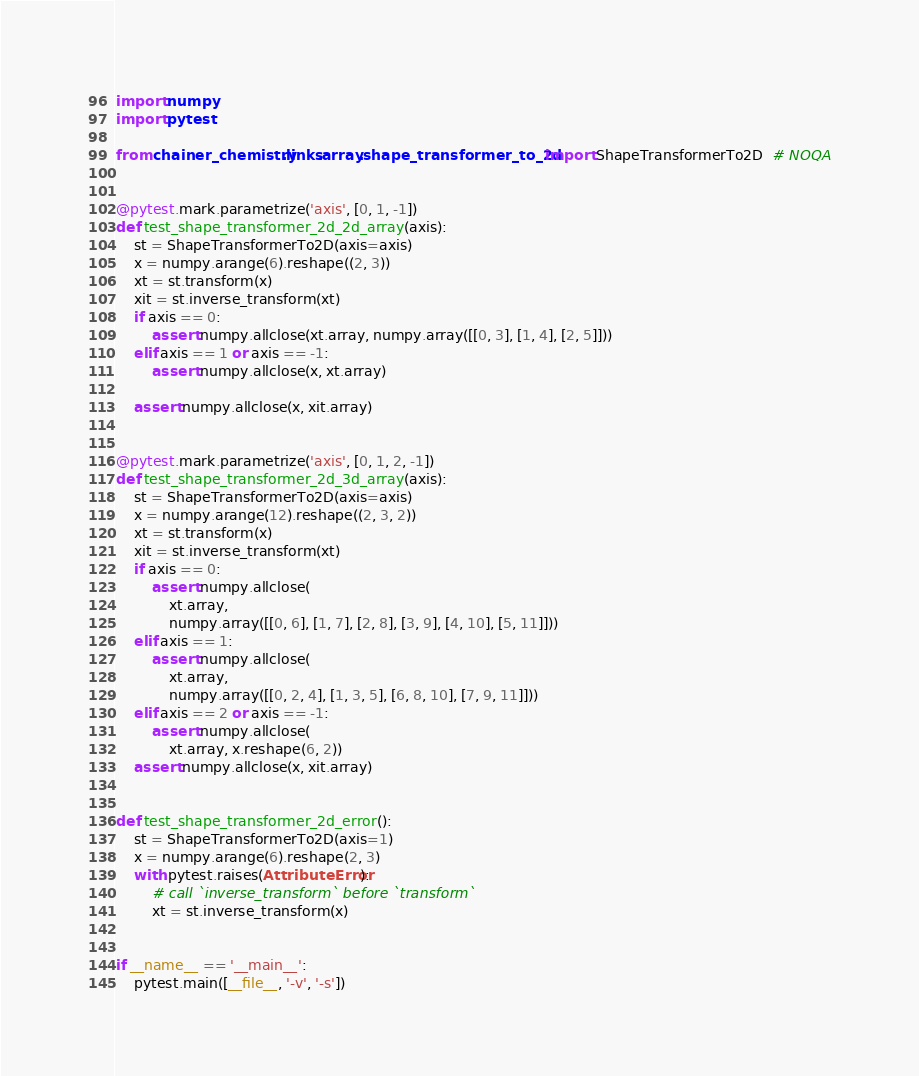<code> <loc_0><loc_0><loc_500><loc_500><_Python_>import numpy
import pytest

from chainer_chemistry.links.array.shape_transformer_to_2d import ShapeTransformerTo2D  # NOQA


@pytest.mark.parametrize('axis', [0, 1, -1])
def test_shape_transformer_2d_2d_array(axis):
    st = ShapeTransformerTo2D(axis=axis)
    x = numpy.arange(6).reshape((2, 3))
    xt = st.transform(x)
    xit = st.inverse_transform(xt)
    if axis == 0:
        assert numpy.allclose(xt.array, numpy.array([[0, 3], [1, 4], [2, 5]]))
    elif axis == 1 or axis == -1:
        assert numpy.allclose(x, xt.array)

    assert numpy.allclose(x, xit.array)


@pytest.mark.parametrize('axis', [0, 1, 2, -1])
def test_shape_transformer_2d_3d_array(axis):
    st = ShapeTransformerTo2D(axis=axis)
    x = numpy.arange(12).reshape((2, 3, 2))
    xt = st.transform(x)
    xit = st.inverse_transform(xt)
    if axis == 0:
        assert numpy.allclose(
            xt.array,
            numpy.array([[0, 6], [1, 7], [2, 8], [3, 9], [4, 10], [5, 11]]))
    elif axis == 1:
        assert numpy.allclose(
            xt.array,
            numpy.array([[0, 2, 4], [1, 3, 5], [6, 8, 10], [7, 9, 11]]))
    elif axis == 2 or axis == -1:
        assert numpy.allclose(
            xt.array, x.reshape(6, 2))
    assert numpy.allclose(x, xit.array)


def test_shape_transformer_2d_error():
    st = ShapeTransformerTo2D(axis=1)
    x = numpy.arange(6).reshape(2, 3)
    with pytest.raises(AttributeError):
        # call `inverse_transform` before `transform`
        xt = st.inverse_transform(x)


if __name__ == '__main__':
    pytest.main([__file__, '-v', '-s'])
</code> 